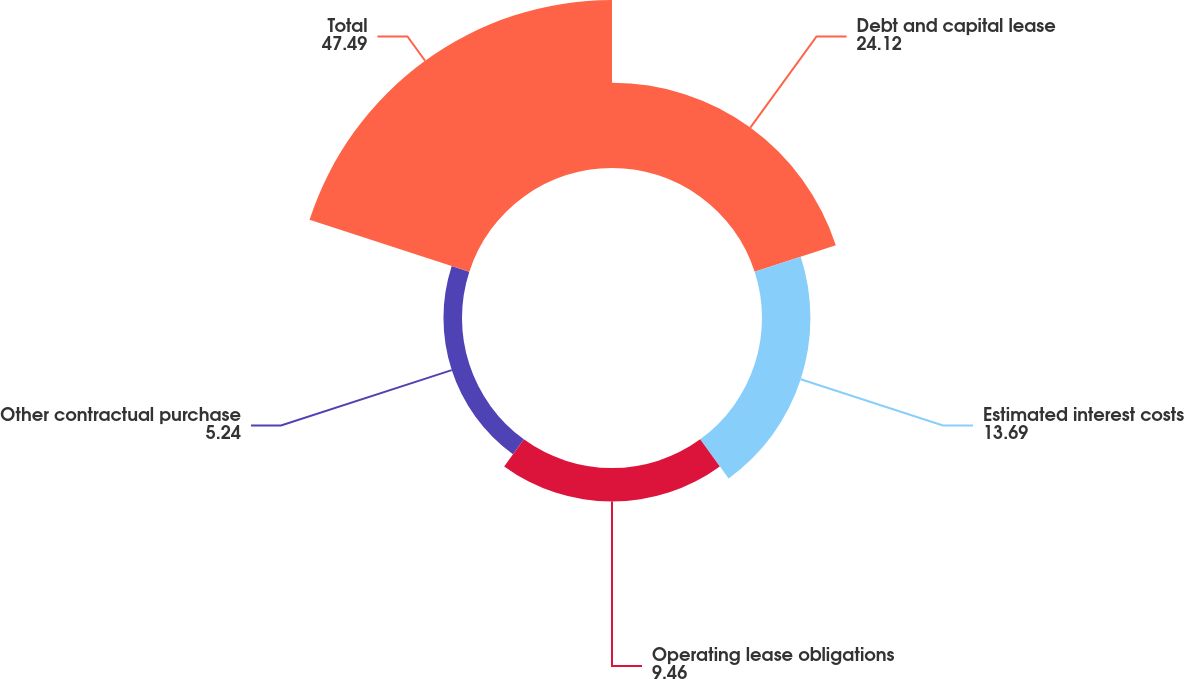Convert chart. <chart><loc_0><loc_0><loc_500><loc_500><pie_chart><fcel>Debt and capital lease<fcel>Estimated interest costs<fcel>Operating lease obligations<fcel>Other contractual purchase<fcel>Total<nl><fcel>24.12%<fcel>13.69%<fcel>9.46%<fcel>5.24%<fcel>47.49%<nl></chart> 